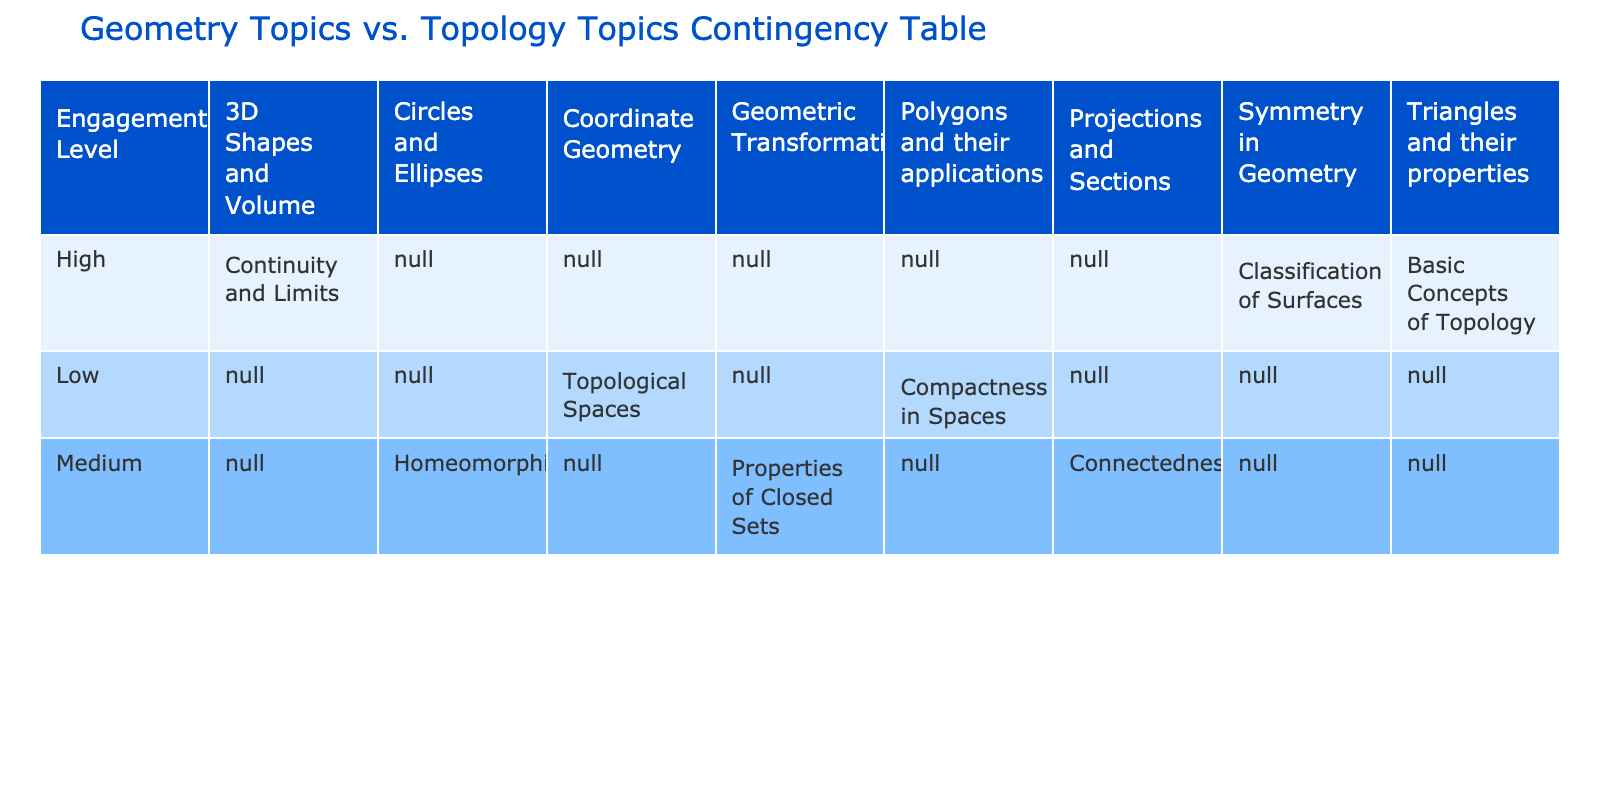What is the highest engagement level recorded in the Geometry Topics? The table shows the engagement levels associated with various geometry topics. I can see that "Triangles and their properties" and "3D Shapes and Volume" are marked under "High." Therefore, the highest engagement level is "High."
Answer: High Which topology topic corresponds to "Medium" engagement with "Polygons and their applications"? In the table, "Polygons and their applications" has a corresponding topology topic listed as "Compactness in Spaces." This links the medium engagement in geometry to this specific topology topic.
Answer: Compactness in Spaces How many different engagement levels are represented in the table? The engagement levels listed in the table are High, Medium, and Low. Counting these gives a total of three distinct engagement levels represented.
Answer: 3 Are there any geometry topics with low engagement? Looking at the table, “Coordinate Geometry” and “Polygons and their applications” are indicated as having low engagement. Therefore, there are geometry topics recorded with low engagement levels.
Answer: Yes What is the difference in the number of high engagement levels between geometry and topology topics? The high engagement levels for geometry topics are “Triangles and their properties” and “3D Shapes and Volume,” totaling 2 instances, while for topology topics there are 3, namely “Basic Concepts of Topology,” “Continuity and Limits,” and “Classification of Surfaces.” The difference in high engagement levels is hence 3 - 2 = 1.
Answer: 1 Which geometry topic has the lowest engagement level? By scanning the table, the geometry topic determined to have the lowest engagement level is “Coordinate Geometry” as it is marked under "Low" alongside another entry.
Answer: Coordinate Geometry What is the total number of unique topology topics listed under Medium engagement? In the table, there are two geometry topics with medium engagement: "Circles and Ellipses" and “Geometric Transformations." Correspondingly, the unique topology topics associated with these are "Homeomorphism" and “Properties of Closed Sets.” This indicates a total of 2 unique topology topics under medium engagement.
Answer: 2 Which geometry topics have high engagement, and do they also have engagement level correspondence in topology? The geometry topics with high engagement are "Triangles and their properties," "3D Shapes and Volume," and "Symmetry in Geometry." Each of these has corresponding topology topics shown, which indicates they do indeed have high engagements associated with them in topology as well.
Answer: Yes 